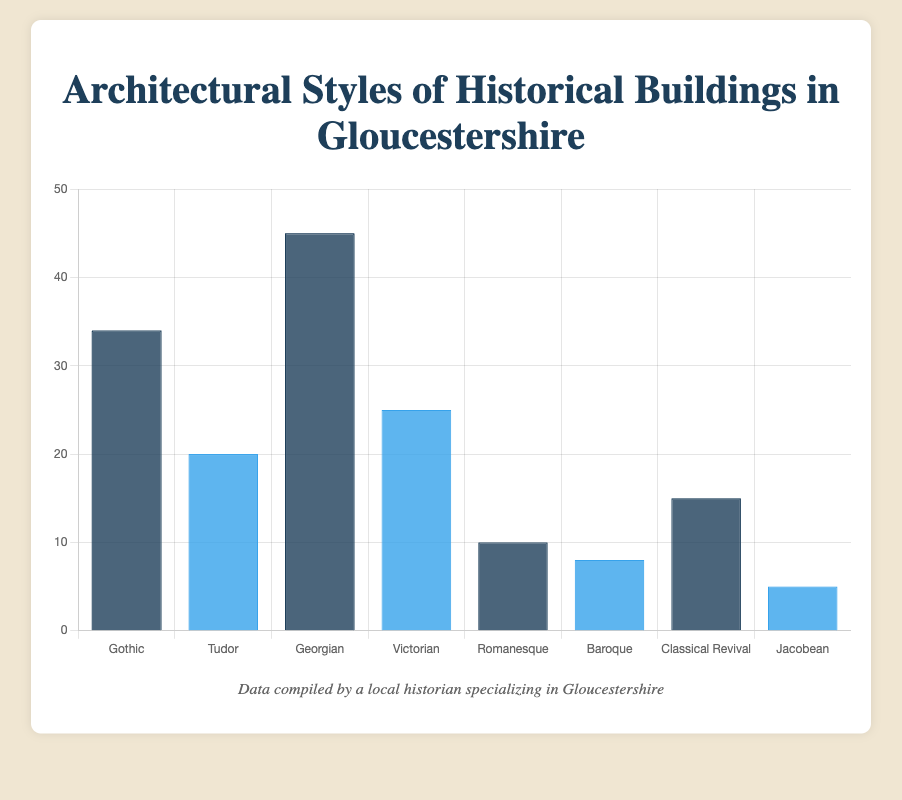Which architectural style has the highest count of buildings? By observing the height of the bars, we can see that the Georgian bar is the tallest. Therefore, the Georgian architectural style has the highest count of buildings.
Answer: Georgian Which two architectural styles combined have exactly 50 buildings? Add up the counts of different styles until you find a sum of 50. Adding Victorian (25) and Classical Revival (15) gives 40. Adding Baroque (8) to that gives 48. Adding Jacobean (5) gives 53, which is too high. However, adding Gothic (34) and Romanesque (10) gives 44, which is closer. Finally, Georgian (45) and Baroque (8) give 53, again too high. The styles Gothic (34) and Victorian (25) sum to 59, closest to 50 but still too high. Therefore, none of the combined counts exactly match 50.
Answer: None What is the ratio of Gothic to Baroque buildings? Divide the count of Gothic buildings by the count of Baroque buildings: 34 / 8.
Answer: 4.25 Are there more Tudor or Classical Revival buildings? Compare the heights of the Tudor and Classical Revival bars. The Tudor bar represents 20 buildings, and the Classical Revival bar represents 15 buildings. Tudor has more buildings.
Answer: Tudor How many more Georgian buildings are there compared to Jacobean? Subtract the count of Jacobean buildings from the count of Georgian buildings: 45 - 5.
Answer: 40 Which architectural style has half the count of the Victorian style? Determine half of the count of Victorian buildings: 25 / 2 = 12.5. The closest style by observation is Romanesque with 10 buildings.
Answer: Romanesque What percentage of the total buildings does the Gothic architectural style represent? First, calculate the total count of all buildings: 34 + 20 + 45 + 25 + 10 + 8 + 15 + 5 = 162. Then, divide the count of Gothic buildings by the total count and multiply by 100: (34 / 162) * 100 ≈ 20.99%.
Answer: 20.99% Which architectural styles have fewer than 10 buildings? Observe the heights of the bars and look for styles with counts under 10. Romanesque (10), Baroque (8), and Jacobean (5) are under 10.
Answer: Baroque, Jacobean Is the count of Victorian buildings closer to Tudor or Classical Revival buildings? Calculate the differences: Victorian to Tudor: 25 - 20 = 5, Victorian to Classical Revival: 25 - 15 = 10. The count of Victorian buildings is closer to Tudor.
Answer: Tudor Which bar has the darkest shade of blue? Observe the bar colors and their corresponding shades of blue. The bars using the darker shades alternate starting with the Gothic bar. Thus, the darkest bar represents Gothic, Georgian, Romanesque, and Classical Revival styles.
Answer: Gothic, Georgian, Romanesque, Classical Revival 